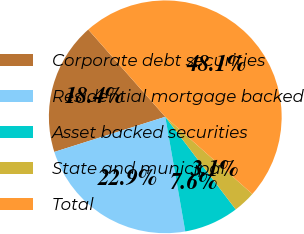Convert chart. <chart><loc_0><loc_0><loc_500><loc_500><pie_chart><fcel>Corporate debt securities<fcel>Residential mortgage backed<fcel>Asset backed securities<fcel>State and municipal<fcel>Total<nl><fcel>18.37%<fcel>22.87%<fcel>7.6%<fcel>3.1%<fcel>48.06%<nl></chart> 